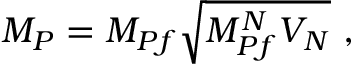Convert formula to latex. <formula><loc_0><loc_0><loc_500><loc_500>M _ { P } = M _ { P f } \sqrt { M _ { P f } ^ { N } V _ { N } } ,</formula> 